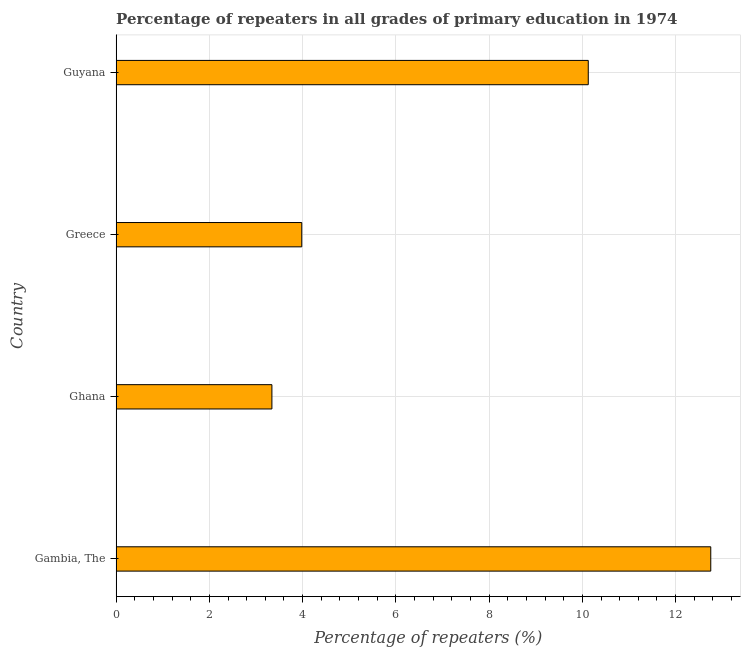Does the graph contain any zero values?
Offer a very short reply. No. What is the title of the graph?
Provide a short and direct response. Percentage of repeaters in all grades of primary education in 1974. What is the label or title of the X-axis?
Your answer should be very brief. Percentage of repeaters (%). What is the percentage of repeaters in primary education in Ghana?
Offer a terse response. 3.34. Across all countries, what is the maximum percentage of repeaters in primary education?
Keep it short and to the point. 12.75. Across all countries, what is the minimum percentage of repeaters in primary education?
Your response must be concise. 3.34. In which country was the percentage of repeaters in primary education maximum?
Your answer should be very brief. Gambia, The. What is the sum of the percentage of repeaters in primary education?
Provide a short and direct response. 30.2. What is the difference between the percentage of repeaters in primary education in Gambia, The and Greece?
Give a very brief answer. 8.77. What is the average percentage of repeaters in primary education per country?
Ensure brevity in your answer.  7.55. What is the median percentage of repeaters in primary education?
Your response must be concise. 7.05. What is the ratio of the percentage of repeaters in primary education in Ghana to that in Greece?
Provide a short and direct response. 0.84. What is the difference between the highest and the second highest percentage of repeaters in primary education?
Your answer should be compact. 2.63. Is the sum of the percentage of repeaters in primary education in Gambia, The and Ghana greater than the maximum percentage of repeaters in primary education across all countries?
Offer a terse response. Yes. What is the difference between the highest and the lowest percentage of repeaters in primary education?
Provide a short and direct response. 9.41. In how many countries, is the percentage of repeaters in primary education greater than the average percentage of repeaters in primary education taken over all countries?
Your response must be concise. 2. How many countries are there in the graph?
Offer a terse response. 4. What is the difference between two consecutive major ticks on the X-axis?
Keep it short and to the point. 2. Are the values on the major ticks of X-axis written in scientific E-notation?
Provide a succinct answer. No. What is the Percentage of repeaters (%) of Gambia, The?
Ensure brevity in your answer.  12.75. What is the Percentage of repeaters (%) in Ghana?
Your response must be concise. 3.34. What is the Percentage of repeaters (%) in Greece?
Make the answer very short. 3.98. What is the Percentage of repeaters (%) of Guyana?
Your answer should be very brief. 10.13. What is the difference between the Percentage of repeaters (%) in Gambia, The and Ghana?
Keep it short and to the point. 9.41. What is the difference between the Percentage of repeaters (%) in Gambia, The and Greece?
Your response must be concise. 8.77. What is the difference between the Percentage of repeaters (%) in Gambia, The and Guyana?
Offer a terse response. 2.63. What is the difference between the Percentage of repeaters (%) in Ghana and Greece?
Offer a terse response. -0.64. What is the difference between the Percentage of repeaters (%) in Ghana and Guyana?
Offer a terse response. -6.79. What is the difference between the Percentage of repeaters (%) in Greece and Guyana?
Your answer should be very brief. -6.15. What is the ratio of the Percentage of repeaters (%) in Gambia, The to that in Ghana?
Keep it short and to the point. 3.82. What is the ratio of the Percentage of repeaters (%) in Gambia, The to that in Greece?
Offer a terse response. 3.2. What is the ratio of the Percentage of repeaters (%) in Gambia, The to that in Guyana?
Offer a very short reply. 1.26. What is the ratio of the Percentage of repeaters (%) in Ghana to that in Greece?
Ensure brevity in your answer.  0.84. What is the ratio of the Percentage of repeaters (%) in Ghana to that in Guyana?
Offer a very short reply. 0.33. What is the ratio of the Percentage of repeaters (%) in Greece to that in Guyana?
Provide a succinct answer. 0.39. 